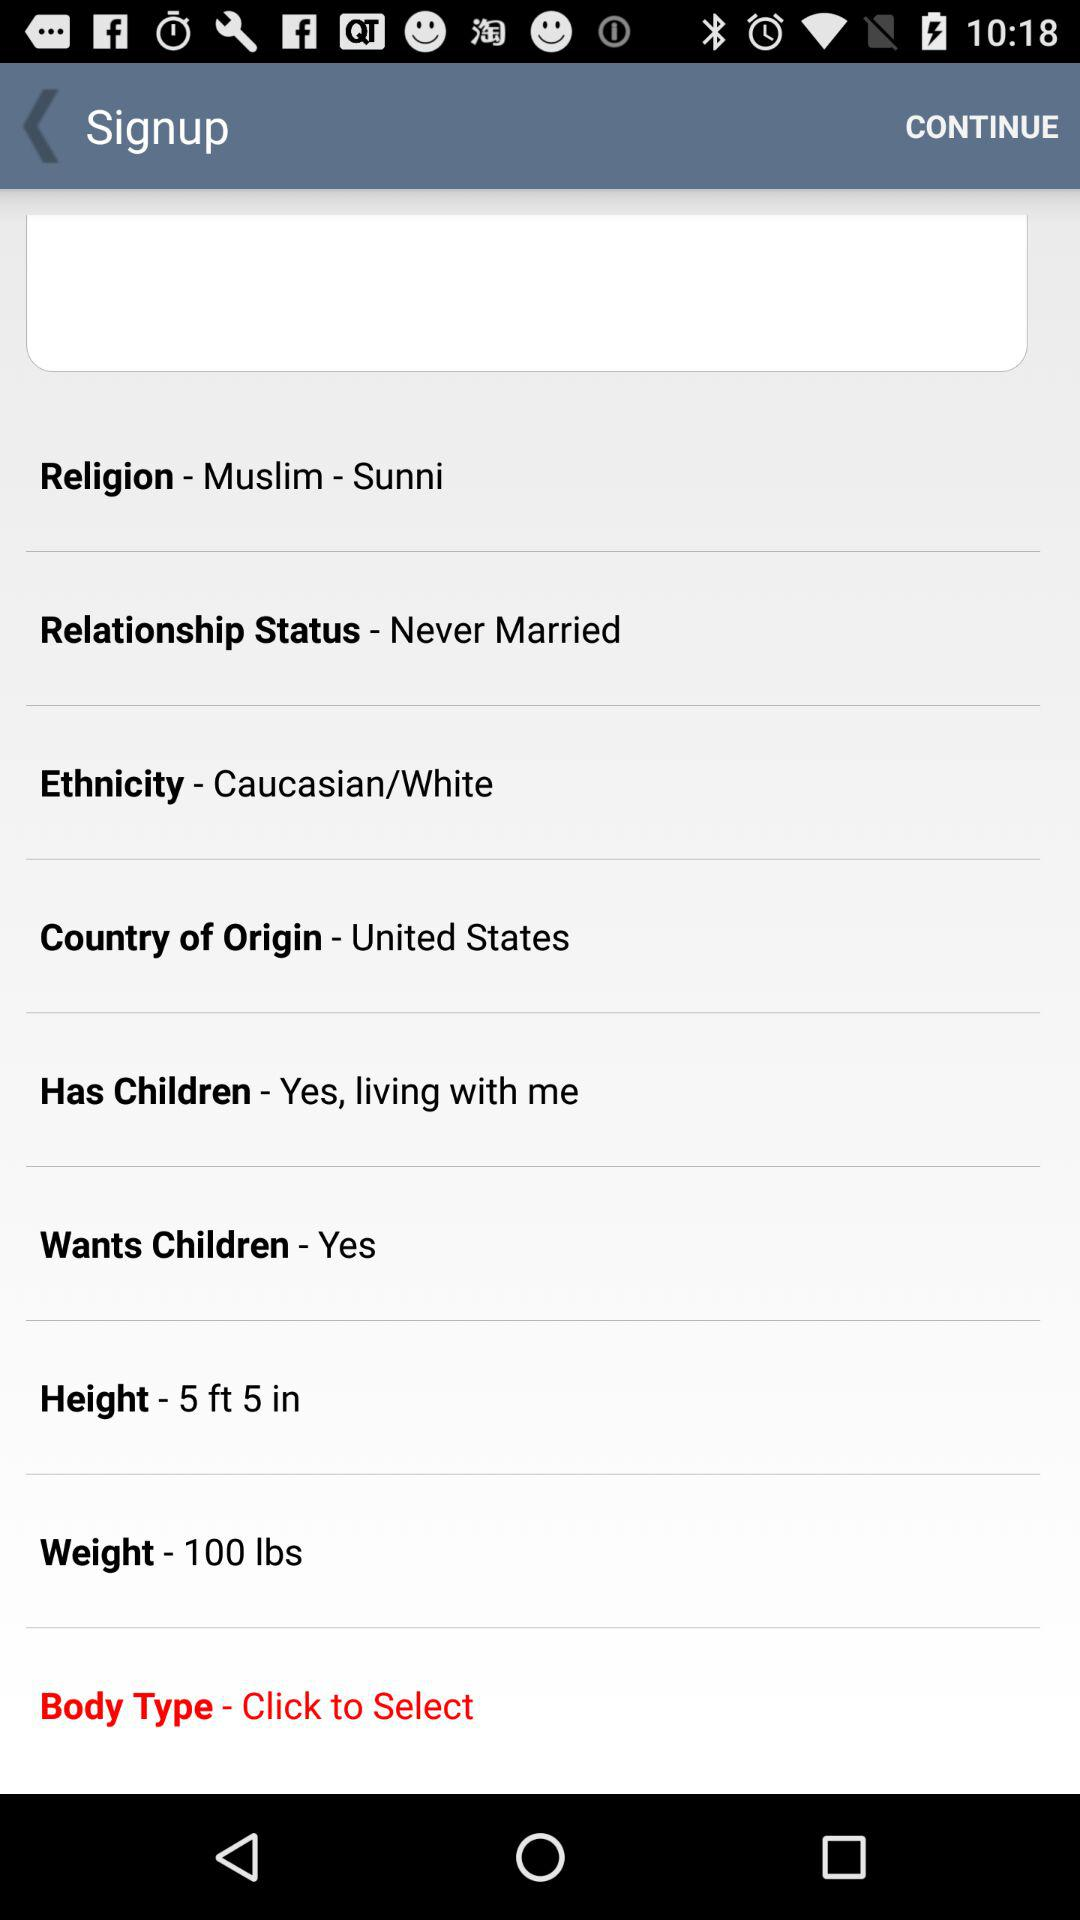What is the height? The height is 5 feet, 5 inches. 